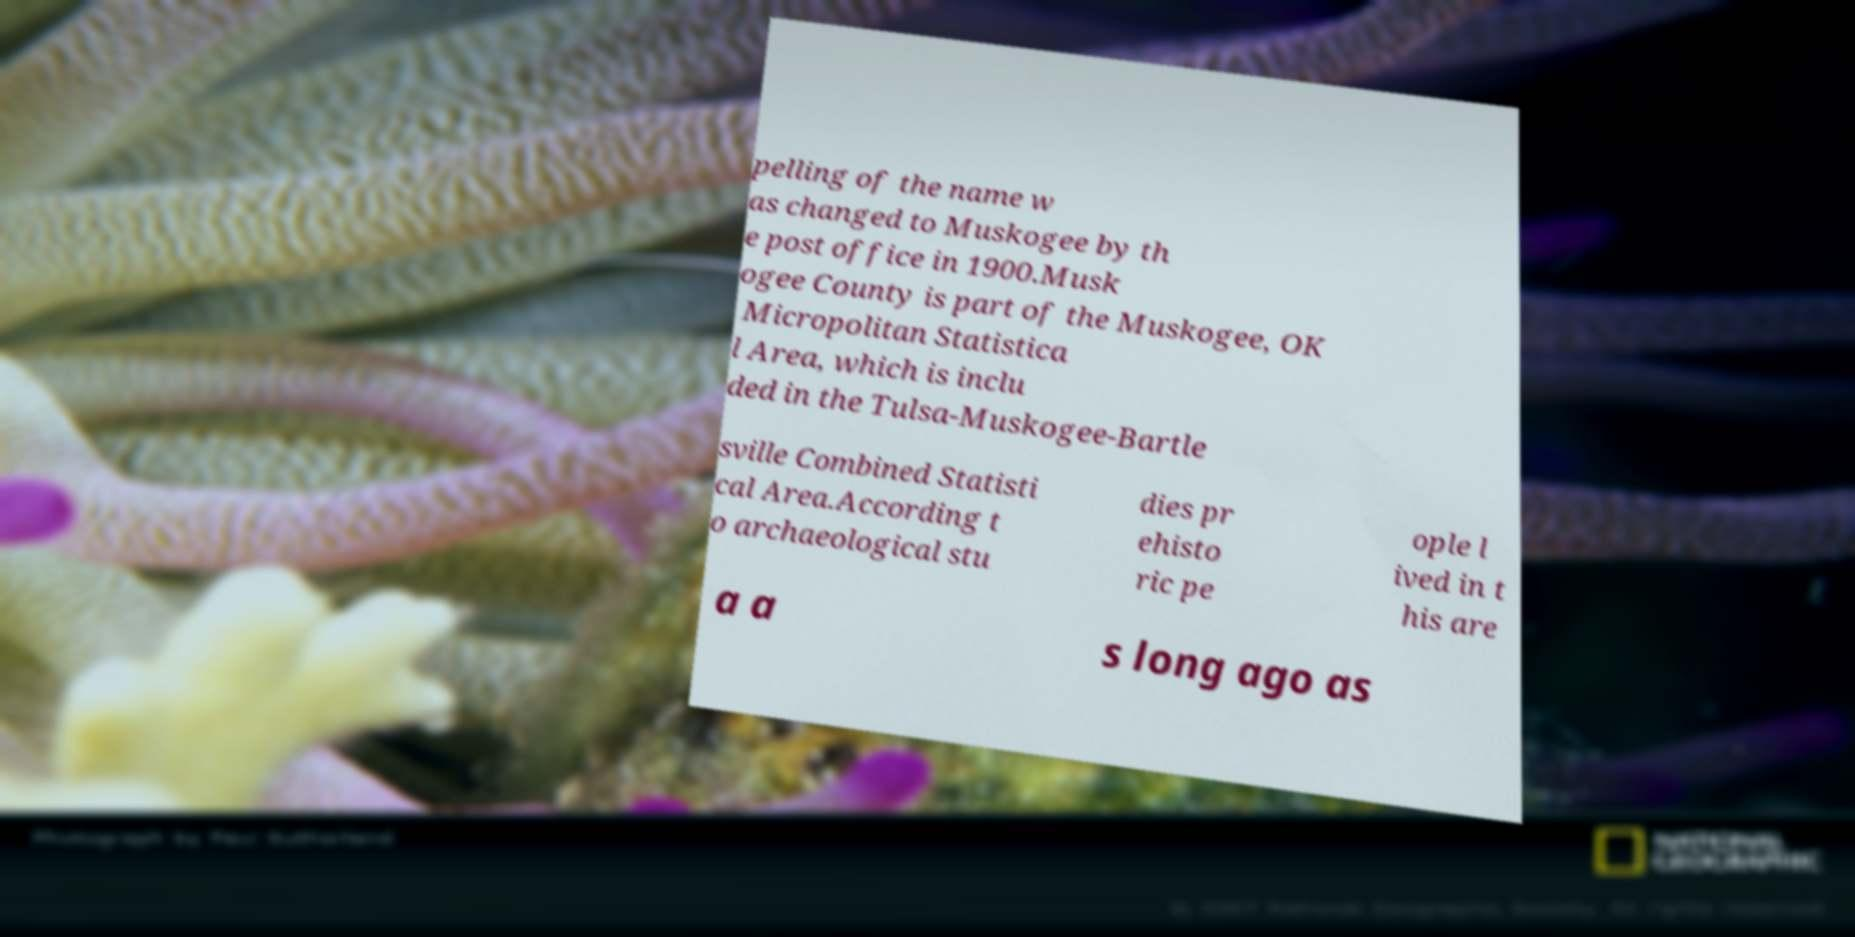There's text embedded in this image that I need extracted. Can you transcribe it verbatim? pelling of the name w as changed to Muskogee by th e post office in 1900.Musk ogee County is part of the Muskogee, OK Micropolitan Statistica l Area, which is inclu ded in the Tulsa-Muskogee-Bartle sville Combined Statisti cal Area.According t o archaeological stu dies pr ehisto ric pe ople l ived in t his are a a s long ago as 